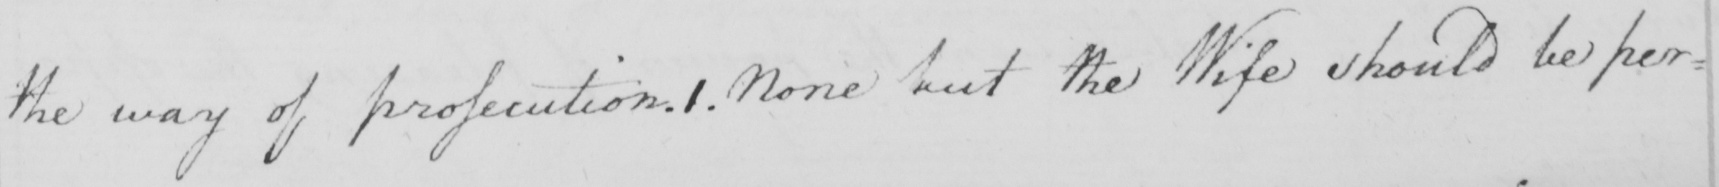What text is written in this handwritten line? the way of prosecution . 1 . None but the Wife should be per= 